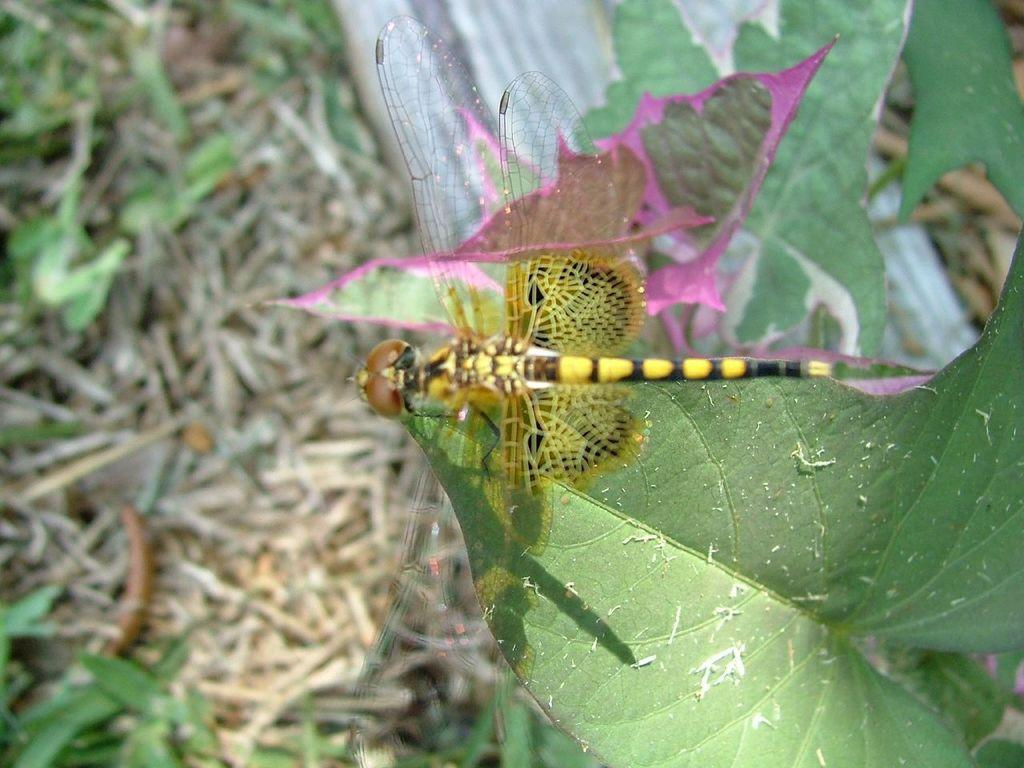What type of insect is in the picture? There is a yellow and green insect in the picture. Where is the insect located? The insect is sitting on a green leaf. Can you describe the background of the image? The background of the image is blurred. What type of feast is the insect attending in the image? There is no indication of a feast or any gathering in the image; it simply shows an insect sitting on a leaf. Does the insect have any visible teeth in the image? Insects do not have teeth like mammals, so there are no visible teeth in the image. 